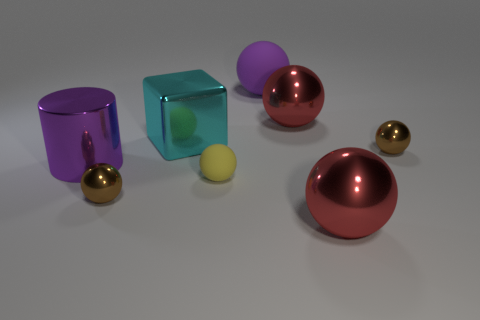Subtract all metallic balls. How many balls are left? 2 Subtract all red spheres. How many spheres are left? 4 Add 1 tiny brown metal objects. How many objects exist? 9 Subtract all green spheres. Subtract all blue cylinders. How many spheres are left? 6 Subtract all yellow blocks. How many green spheres are left? 0 Subtract all small brown rubber blocks. Subtract all big metallic blocks. How many objects are left? 7 Add 5 tiny yellow matte things. How many tiny yellow matte things are left? 6 Add 2 big cyan metal objects. How many big cyan metal objects exist? 3 Subtract 1 brown spheres. How many objects are left? 7 Subtract all cylinders. How many objects are left? 7 